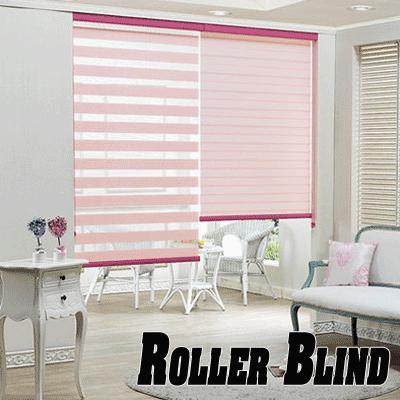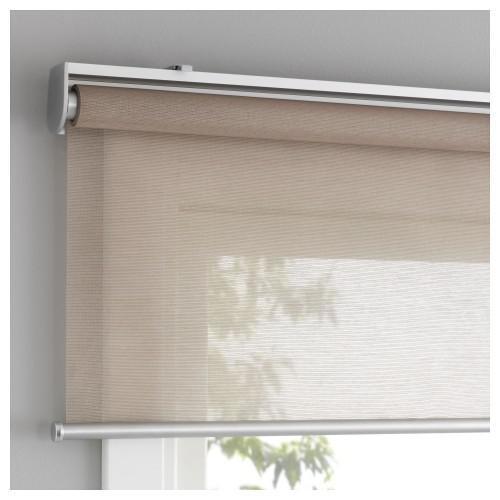The first image is the image on the left, the second image is the image on the right. Examine the images to the left and right. Is the description "In at least one image there are three blue shades partly open." accurate? Answer yes or no. No. The first image is the image on the left, the second image is the image on the right. Analyze the images presented: Is the assertion "One image is just a window, while the other is a room." valid? Answer yes or no. Yes. 